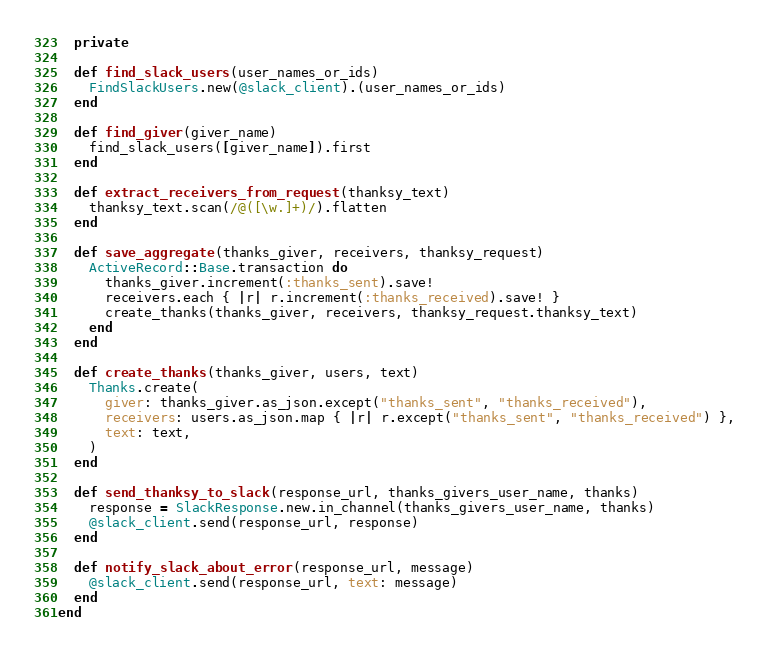Convert code to text. <code><loc_0><loc_0><loc_500><loc_500><_Ruby_>
  private

  def find_slack_users(user_names_or_ids)
    FindSlackUsers.new(@slack_client).(user_names_or_ids)
  end

  def find_giver(giver_name)
    find_slack_users([giver_name]).first
  end

  def extract_receivers_from_request(thanksy_text)
    thanksy_text.scan(/@([\w.]+)/).flatten
  end

  def save_aggregate(thanks_giver, receivers, thanksy_request)
    ActiveRecord::Base.transaction do
      thanks_giver.increment(:thanks_sent).save!
      receivers.each { |r| r.increment(:thanks_received).save! }
      create_thanks(thanks_giver, receivers, thanksy_request.thanksy_text)
    end
  end

  def create_thanks(thanks_giver, users, text)
    Thanks.create(
      giver: thanks_giver.as_json.except("thanks_sent", "thanks_received"),
      receivers: users.as_json.map { |r| r.except("thanks_sent", "thanks_received") },
      text: text,
    )
  end

  def send_thanksy_to_slack(response_url, thanks_givers_user_name, thanks)
    response = SlackResponse.new.in_channel(thanks_givers_user_name, thanks)
    @slack_client.send(response_url, response)
  end

  def notify_slack_about_error(response_url, message)
    @slack_client.send(response_url, text: message)
  end
end
</code> 